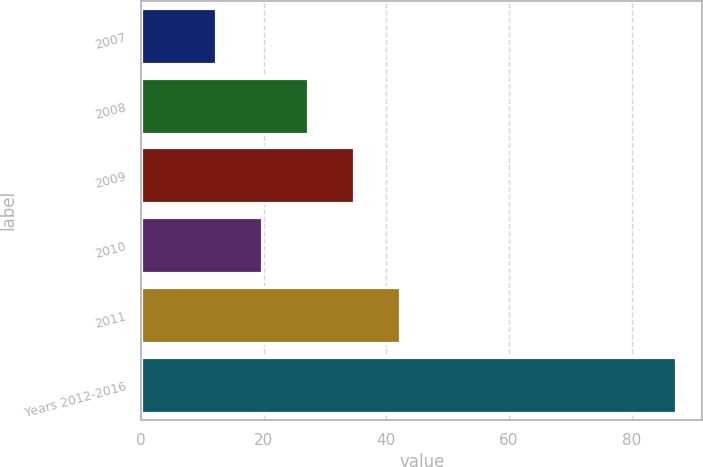Convert chart to OTSL. <chart><loc_0><loc_0><loc_500><loc_500><bar_chart><fcel>2007<fcel>2008<fcel>2009<fcel>2010<fcel>2011<fcel>Years 2012-2016<nl><fcel>12.2<fcel>27.2<fcel>34.7<fcel>19.7<fcel>42.2<fcel>87.2<nl></chart> 